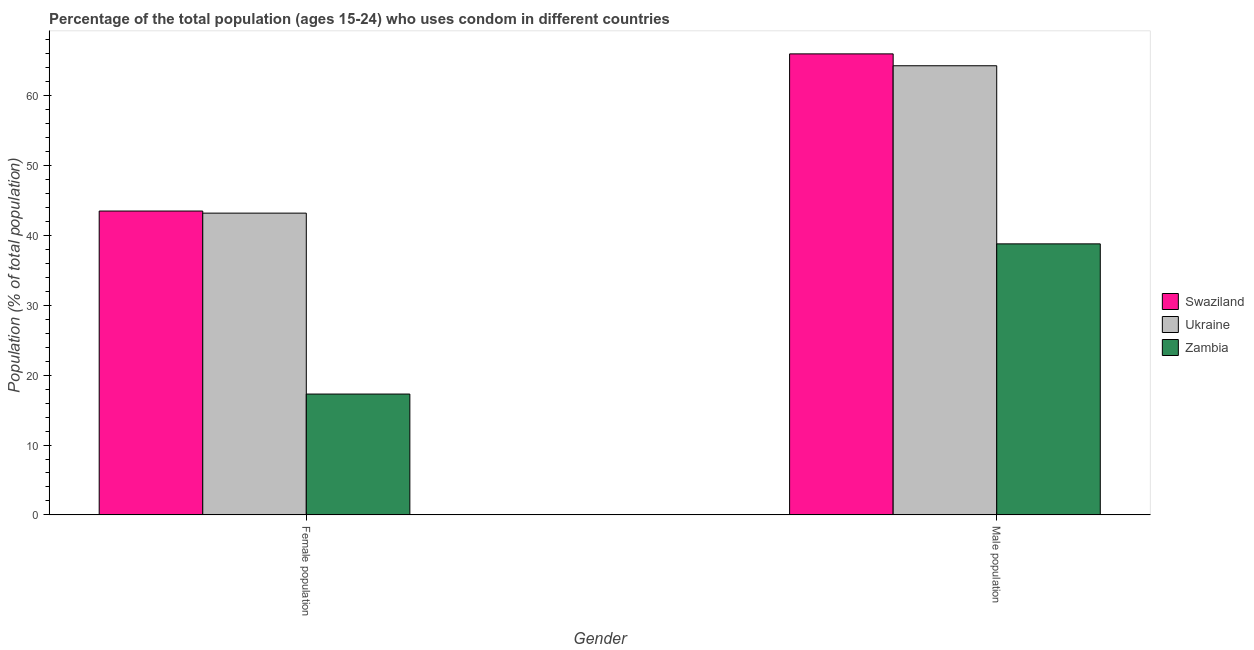How many groups of bars are there?
Offer a very short reply. 2. Are the number of bars per tick equal to the number of legend labels?
Keep it short and to the point. Yes. How many bars are there on the 2nd tick from the left?
Your answer should be very brief. 3. What is the label of the 2nd group of bars from the left?
Your answer should be compact. Male population. What is the female population in Zambia?
Offer a very short reply. 17.3. Across all countries, what is the maximum female population?
Offer a very short reply. 43.5. Across all countries, what is the minimum female population?
Make the answer very short. 17.3. In which country was the female population maximum?
Offer a terse response. Swaziland. In which country was the male population minimum?
Your response must be concise. Zambia. What is the total male population in the graph?
Your answer should be very brief. 169.1. What is the difference between the female population in Swaziland and that in Zambia?
Make the answer very short. 26.2. What is the difference between the female population in Ukraine and the male population in Swaziland?
Give a very brief answer. -22.8. What is the average female population per country?
Make the answer very short. 34.67. What is the difference between the male population and female population in Zambia?
Your response must be concise. 21.5. In how many countries, is the male population greater than 48 %?
Offer a terse response. 2. What is the ratio of the female population in Zambia to that in Ukraine?
Offer a very short reply. 0.4. Is the male population in Swaziland less than that in Ukraine?
Provide a succinct answer. No. What does the 2nd bar from the left in Female population represents?
Give a very brief answer. Ukraine. What does the 3rd bar from the right in Male population represents?
Keep it short and to the point. Swaziland. How many bars are there?
Your response must be concise. 6. Are all the bars in the graph horizontal?
Offer a very short reply. No. How many countries are there in the graph?
Give a very brief answer. 3. Are the values on the major ticks of Y-axis written in scientific E-notation?
Provide a short and direct response. No. Does the graph contain any zero values?
Make the answer very short. No. Where does the legend appear in the graph?
Make the answer very short. Center right. How many legend labels are there?
Offer a terse response. 3. What is the title of the graph?
Keep it short and to the point. Percentage of the total population (ages 15-24) who uses condom in different countries. Does "Macedonia" appear as one of the legend labels in the graph?
Ensure brevity in your answer.  No. What is the label or title of the X-axis?
Offer a very short reply. Gender. What is the label or title of the Y-axis?
Your answer should be very brief. Population (% of total population) . What is the Population (% of total population)  of Swaziland in Female population?
Your answer should be very brief. 43.5. What is the Population (% of total population)  in Ukraine in Female population?
Provide a short and direct response. 43.2. What is the Population (% of total population)  of Swaziland in Male population?
Provide a succinct answer. 66. What is the Population (% of total population)  of Ukraine in Male population?
Give a very brief answer. 64.3. What is the Population (% of total population)  of Zambia in Male population?
Your response must be concise. 38.8. Across all Gender, what is the maximum Population (% of total population)  of Swaziland?
Your response must be concise. 66. Across all Gender, what is the maximum Population (% of total population)  in Ukraine?
Give a very brief answer. 64.3. Across all Gender, what is the maximum Population (% of total population)  in Zambia?
Provide a succinct answer. 38.8. Across all Gender, what is the minimum Population (% of total population)  in Swaziland?
Provide a succinct answer. 43.5. Across all Gender, what is the minimum Population (% of total population)  in Ukraine?
Your answer should be compact. 43.2. Across all Gender, what is the minimum Population (% of total population)  of Zambia?
Offer a very short reply. 17.3. What is the total Population (% of total population)  of Swaziland in the graph?
Keep it short and to the point. 109.5. What is the total Population (% of total population)  of Ukraine in the graph?
Your response must be concise. 107.5. What is the total Population (% of total population)  of Zambia in the graph?
Your answer should be very brief. 56.1. What is the difference between the Population (% of total population)  of Swaziland in Female population and that in Male population?
Make the answer very short. -22.5. What is the difference between the Population (% of total population)  in Ukraine in Female population and that in Male population?
Your answer should be very brief. -21.1. What is the difference between the Population (% of total population)  of Zambia in Female population and that in Male population?
Keep it short and to the point. -21.5. What is the difference between the Population (% of total population)  in Swaziland in Female population and the Population (% of total population)  in Ukraine in Male population?
Your answer should be compact. -20.8. What is the average Population (% of total population)  of Swaziland per Gender?
Make the answer very short. 54.75. What is the average Population (% of total population)  of Ukraine per Gender?
Offer a very short reply. 53.75. What is the average Population (% of total population)  of Zambia per Gender?
Your response must be concise. 28.05. What is the difference between the Population (% of total population)  of Swaziland and Population (% of total population)  of Ukraine in Female population?
Ensure brevity in your answer.  0.3. What is the difference between the Population (% of total population)  of Swaziland and Population (% of total population)  of Zambia in Female population?
Give a very brief answer. 26.2. What is the difference between the Population (% of total population)  in Ukraine and Population (% of total population)  in Zambia in Female population?
Offer a very short reply. 25.9. What is the difference between the Population (% of total population)  of Swaziland and Population (% of total population)  of Ukraine in Male population?
Provide a succinct answer. 1.7. What is the difference between the Population (% of total population)  of Swaziland and Population (% of total population)  of Zambia in Male population?
Keep it short and to the point. 27.2. What is the difference between the Population (% of total population)  in Ukraine and Population (% of total population)  in Zambia in Male population?
Provide a short and direct response. 25.5. What is the ratio of the Population (% of total population)  of Swaziland in Female population to that in Male population?
Offer a very short reply. 0.66. What is the ratio of the Population (% of total population)  in Ukraine in Female population to that in Male population?
Provide a succinct answer. 0.67. What is the ratio of the Population (% of total population)  in Zambia in Female population to that in Male population?
Offer a very short reply. 0.45. What is the difference between the highest and the second highest Population (% of total population)  in Swaziland?
Provide a succinct answer. 22.5. What is the difference between the highest and the second highest Population (% of total population)  of Ukraine?
Provide a succinct answer. 21.1. What is the difference between the highest and the second highest Population (% of total population)  of Zambia?
Give a very brief answer. 21.5. What is the difference between the highest and the lowest Population (% of total population)  in Ukraine?
Provide a succinct answer. 21.1. 